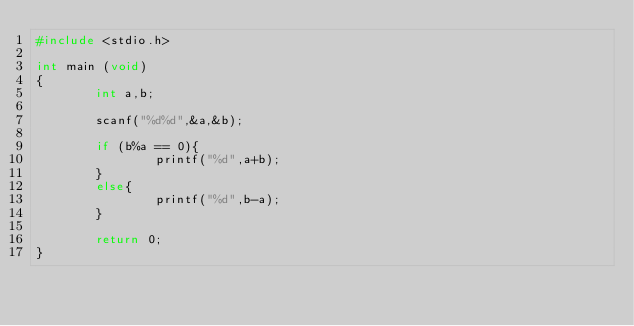Convert code to text. <code><loc_0><loc_0><loc_500><loc_500><_C_>#include <stdio.h>

int main (void)
{
        int a,b;

        scanf("%d%d",&a,&b);

        if (b%a == 0){
                printf("%d",a+b);
        }
        else{
                printf("%d",b-a);
        }

        return 0;
}
</code> 